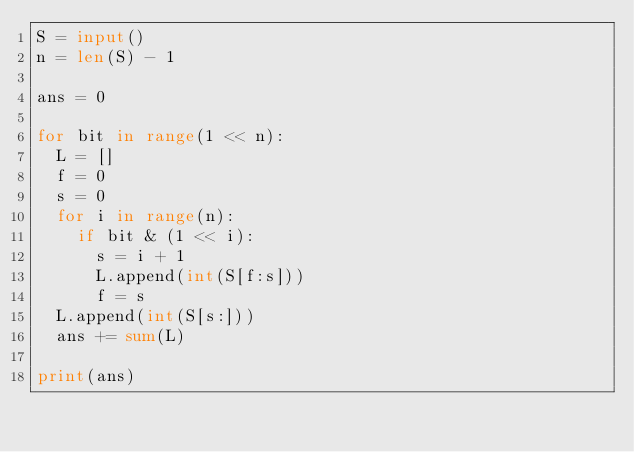<code> <loc_0><loc_0><loc_500><loc_500><_Python_>S = input()
n = len(S) - 1

ans = 0

for bit in range(1 << n):
	L = []
	f = 0
	s = 0
	for i in range(n):
		if bit & (1 << i):
			s = i + 1
			L.append(int(S[f:s]))
			f = s
	L.append(int(S[s:]))
	ans += sum(L)

print(ans)</code> 